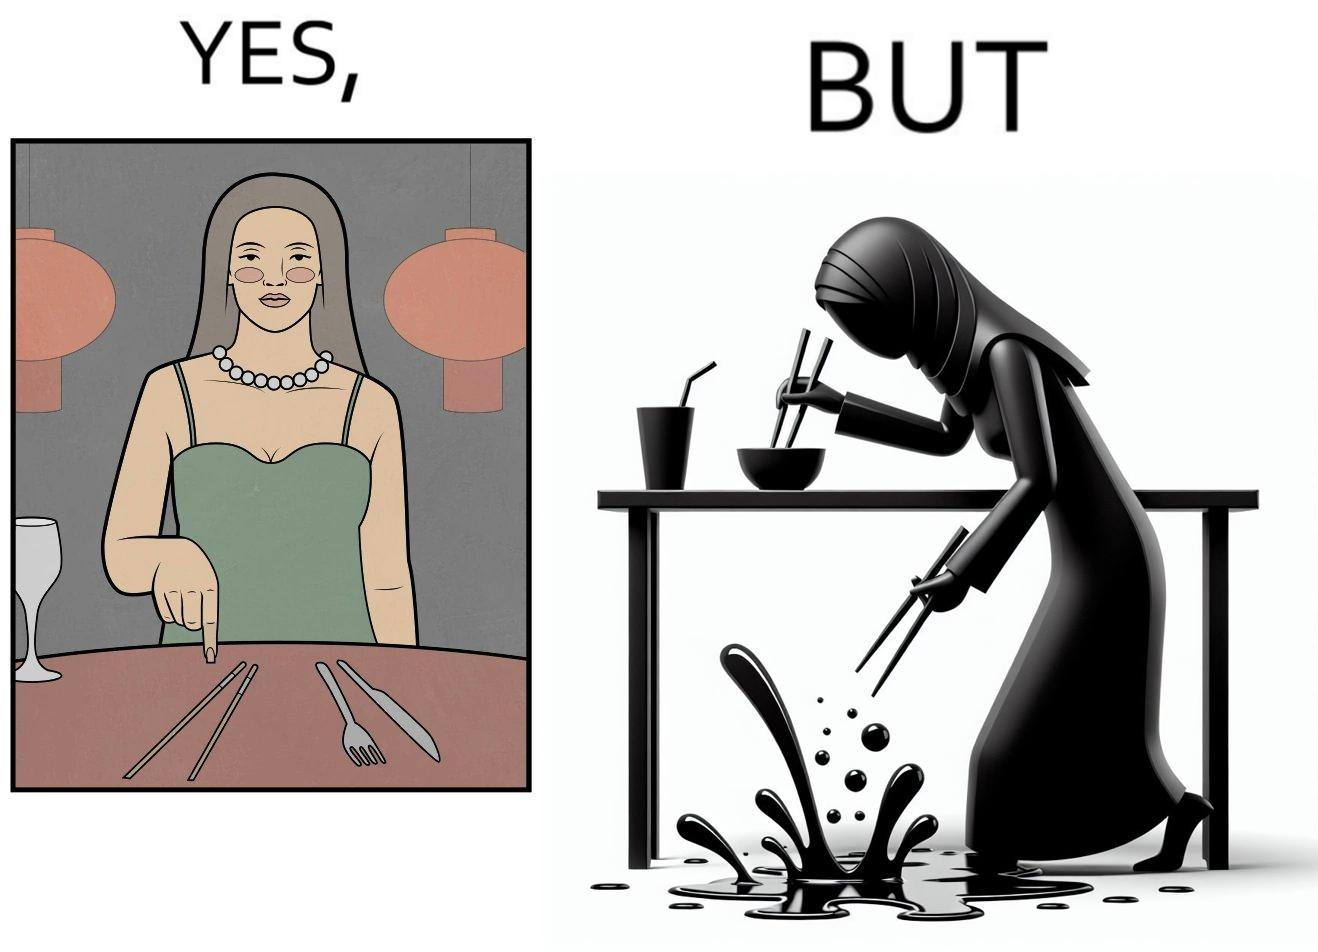Would you classify this image as satirical? Yes, this image is satirical. 